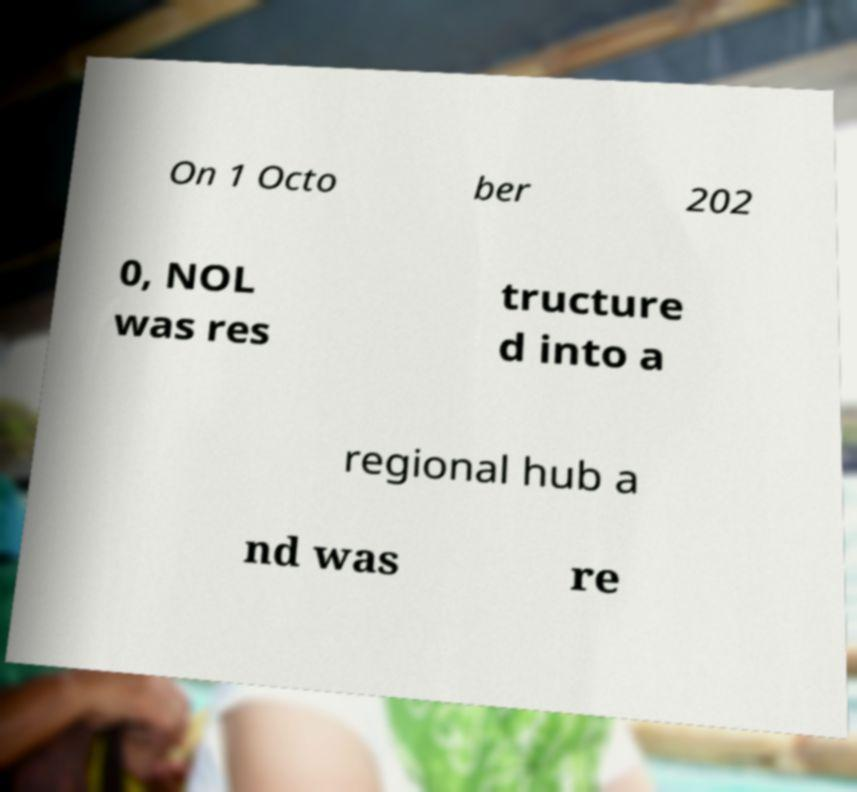There's text embedded in this image that I need extracted. Can you transcribe it verbatim? On 1 Octo ber 202 0, NOL was res tructure d into a regional hub a nd was re 